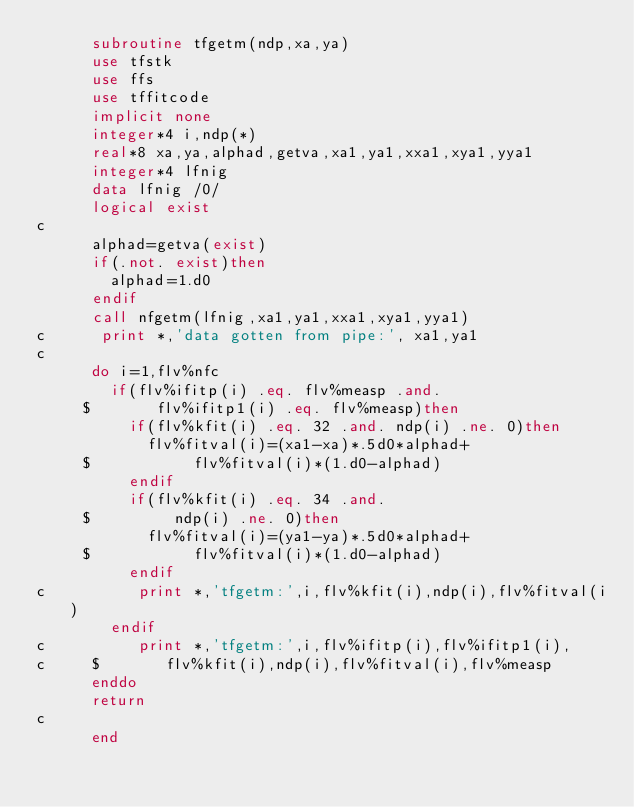Convert code to text. <code><loc_0><loc_0><loc_500><loc_500><_FORTRAN_>      subroutine tfgetm(ndp,xa,ya)
      use tfstk
      use ffs
      use tffitcode
      implicit none
      integer*4 i,ndp(*)
      real*8 xa,ya,alphad,getva,xa1,ya1,xxa1,xya1,yya1
      integer*4 lfnig
      data lfnig /0/
      logical exist
c
      alphad=getva(exist)
      if(.not. exist)then
        alphad=1.d0
      endif
      call nfgetm(lfnig,xa1,ya1,xxa1,xya1,yya1)
c      print *,'data gotten from pipe:', xa1,ya1
c
      do i=1,flv%nfc
        if(flv%ifitp(i) .eq. flv%measp .and.
     $       flv%ifitp1(i) .eq. flv%measp)then
          if(flv%kfit(i) .eq. 32 .and. ndp(i) .ne. 0)then
            flv%fitval(i)=(xa1-xa)*.5d0*alphad+
     $           flv%fitval(i)*(1.d0-alphad)
          endif
          if(flv%kfit(i) .eq. 34 .and.
     $         ndp(i) .ne. 0)then
            flv%fitval(i)=(ya1-ya)*.5d0*alphad+
     $           flv%fitval(i)*(1.d0-alphad)
          endif
c          print *,'tfgetm:',i,flv%kfit(i),ndp(i),flv%fitval(i)
        endif
c          print *,'tfgetm:',i,flv%ifitp(i),flv%ifitp1(i),
c     $       flv%kfit(i),ndp(i),flv%fitval(i),flv%measp
      enddo
      return
c
      end
</code> 